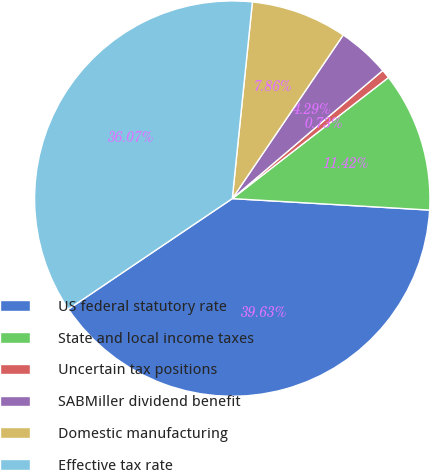<chart> <loc_0><loc_0><loc_500><loc_500><pie_chart><fcel>US federal statutory rate<fcel>State and local income taxes<fcel>Uncertain tax positions<fcel>SABMiller dividend benefit<fcel>Domestic manufacturing<fcel>Effective tax rate<nl><fcel>39.63%<fcel>11.42%<fcel>0.73%<fcel>4.29%<fcel>7.86%<fcel>36.07%<nl></chart> 